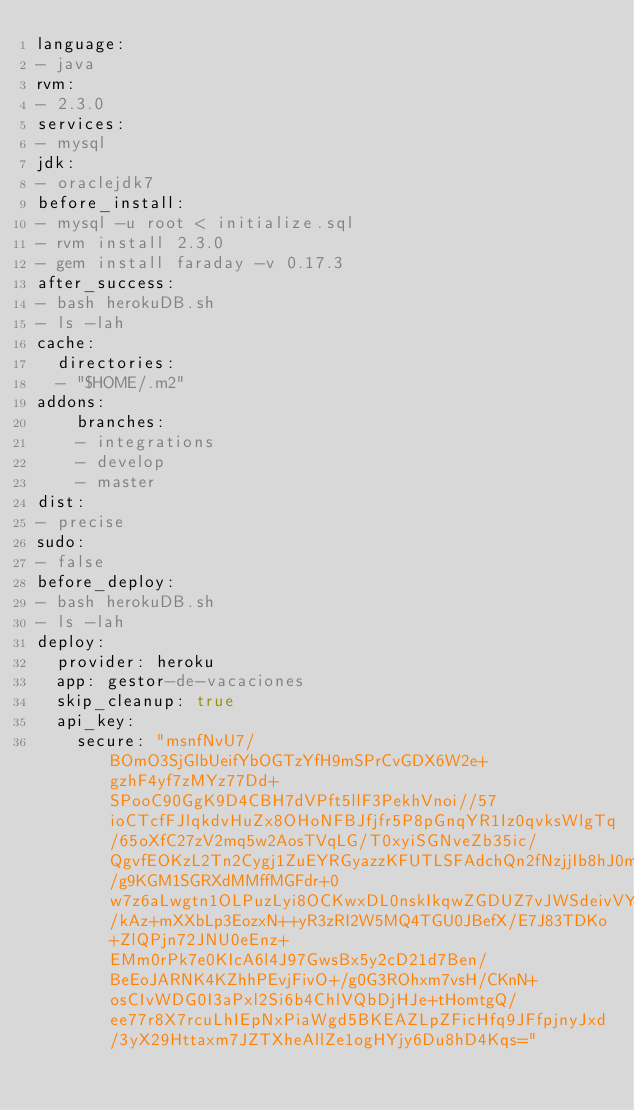Convert code to text. <code><loc_0><loc_0><loc_500><loc_500><_YAML_>language:
- java
rvm:
- 2.3.0
services:
- mysql
jdk:
- oraclejdk7
before_install:
- mysql -u root < initialize.sql
- rvm install 2.3.0
- gem install faraday -v 0.17.3
after_success:
- bash herokuDB.sh
- ls -lah
cache:
  directories:
  - "$HOME/.m2"
addons:
    branches:
    - integrations
    - develop
    - master
dist:
- precise
sudo:
- false
before_deploy:
- bash herokuDB.sh
- ls -lah
deploy:
  provider: heroku
  app: gestor-de-vacaciones
  skip_cleanup: true
  api_key:
    secure: "msnfNvU7/BOmO3SjGlbUeifYbOGTzYfH9mSPrCvGDX6W2e+gzhF4yf7zMYz77Dd+SPooC90GgK9D4CBH7dVPft5llF3PekhVnoi//57ioCTcfFJlqkdvHuZx8OHoNFBJfjfr5P8pGnqYR1Iz0qvksWlgTq/65oXfC27zV2mq5w2AosTVqLG/T0xyiSGNveZb35ic/QgvfEOKzL2Tn2Cygj1ZuEYRGyazzKFUTLSFAdchQn2fNzjjIb8hJ0myM4JO68iGSNQZkFg1P2DUHc9e085/g9KGM1SGRXdMMffMGFdr+0w7z6aLwgtn1OLPuzLyi8OCKwxDL0nskIkqwZGDUZ7vJWSdeivVYfZ6vryBHis3Pl6a6iEKUTfjcO6OC7lchkmtkUXBjCyN9ojxl6/kAz+mXXbLp3EozxN++yR3zRI2W5MQ4TGU0JBefX/E7J83TDKo+ZlQPjn72JNU0eEnz+EMm0rPk7e0KIcA6l4J97GwsBx5y2cD21d7Ben/BeEoJARNK4KZhhPEvjFivO+/g0G3ROhxm7vsH/CKnN+osCIvWDG0I3aPxl2Si6b4ChlVQbDjHJe+tHomtgQ/ee77r8X7rcuLhIEpNxPiaWgd5BKEAZLpZFicHfq9JFfpjnyJxd/3yX29Httaxm7JZTXheAllZe1ogHYjy6Du8hD4Kqs="
</code> 